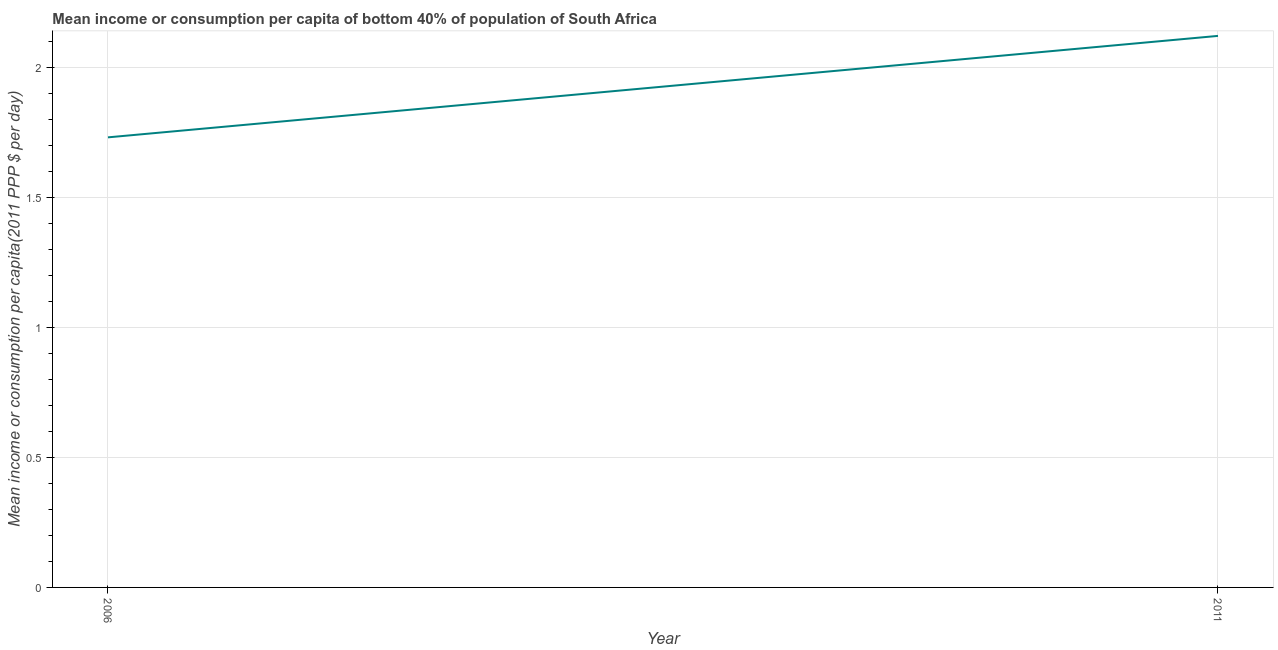What is the mean income or consumption in 2011?
Your response must be concise. 2.12. Across all years, what is the maximum mean income or consumption?
Provide a succinct answer. 2.12. Across all years, what is the minimum mean income or consumption?
Keep it short and to the point. 1.73. In which year was the mean income or consumption minimum?
Offer a terse response. 2006. What is the sum of the mean income or consumption?
Your response must be concise. 3.85. What is the difference between the mean income or consumption in 2006 and 2011?
Your response must be concise. -0.39. What is the average mean income or consumption per year?
Make the answer very short. 1.93. What is the median mean income or consumption?
Keep it short and to the point. 1.93. In how many years, is the mean income or consumption greater than 0.30000000000000004 $?
Make the answer very short. 2. What is the ratio of the mean income or consumption in 2006 to that in 2011?
Your answer should be very brief. 0.82. Does the mean income or consumption monotonically increase over the years?
Your response must be concise. Yes. How many lines are there?
Your answer should be compact. 1. What is the difference between two consecutive major ticks on the Y-axis?
Make the answer very short. 0.5. Are the values on the major ticks of Y-axis written in scientific E-notation?
Offer a very short reply. No. What is the title of the graph?
Give a very brief answer. Mean income or consumption per capita of bottom 40% of population of South Africa. What is the label or title of the Y-axis?
Give a very brief answer. Mean income or consumption per capita(2011 PPP $ per day). What is the Mean income or consumption per capita(2011 PPP $ per day) in 2006?
Give a very brief answer. 1.73. What is the Mean income or consumption per capita(2011 PPP $ per day) in 2011?
Provide a short and direct response. 2.12. What is the difference between the Mean income or consumption per capita(2011 PPP $ per day) in 2006 and 2011?
Give a very brief answer. -0.39. What is the ratio of the Mean income or consumption per capita(2011 PPP $ per day) in 2006 to that in 2011?
Your response must be concise. 0.82. 